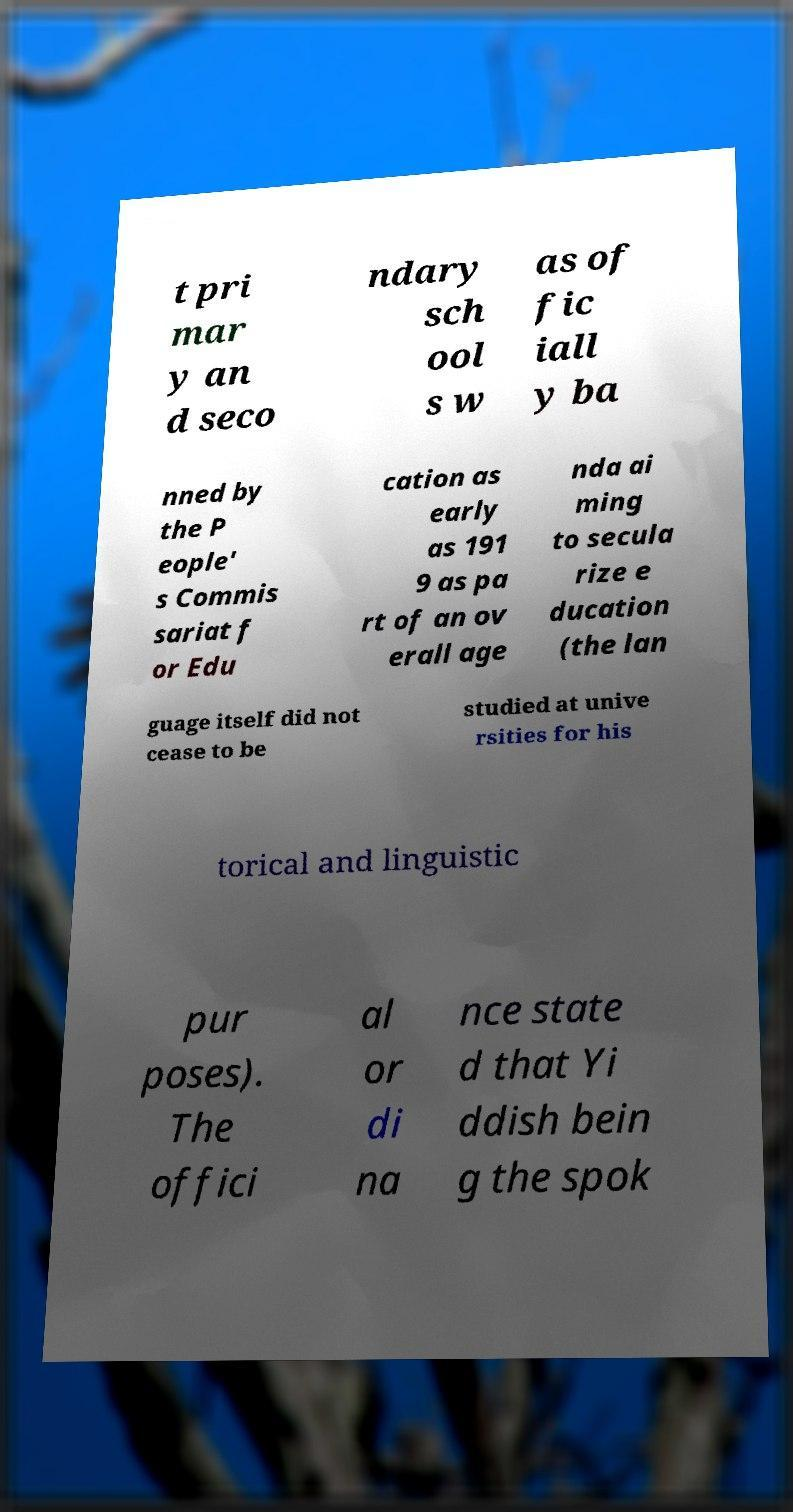I need the written content from this picture converted into text. Can you do that? t pri mar y an d seco ndary sch ool s w as of fic iall y ba nned by the P eople' s Commis sariat f or Edu cation as early as 191 9 as pa rt of an ov erall age nda ai ming to secula rize e ducation (the lan guage itself did not cease to be studied at unive rsities for his torical and linguistic pur poses). The offici al or di na nce state d that Yi ddish bein g the spok 